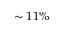Convert formula to latex. <formula><loc_0><loc_0><loc_500><loc_500>\sim 1 1 \%</formula> 